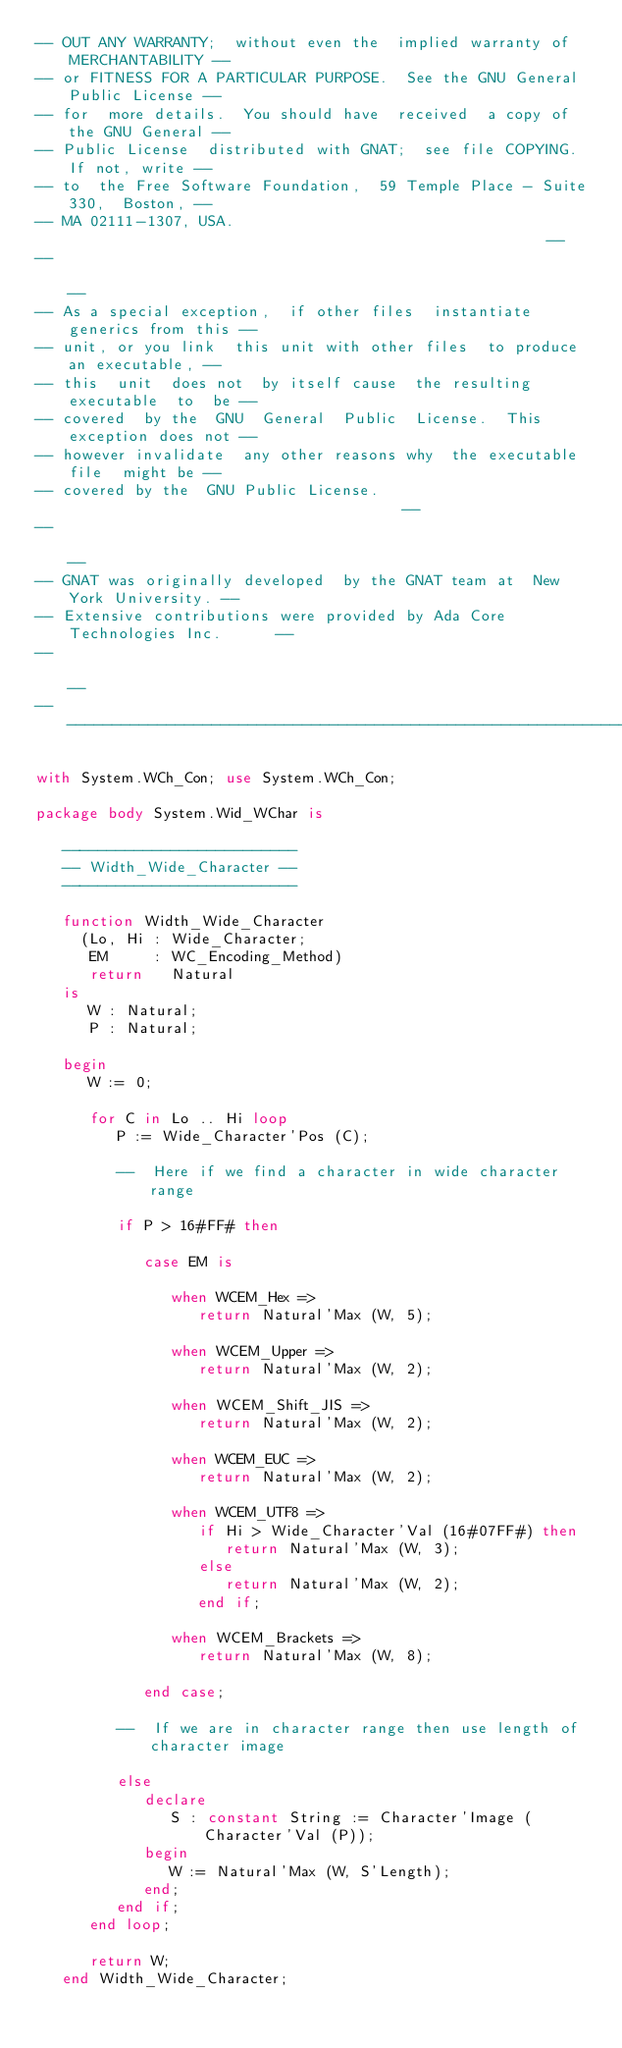<code> <loc_0><loc_0><loc_500><loc_500><_Ada_>-- OUT ANY WARRANTY;  without even the  implied warranty of MERCHANTABILITY --
-- or FITNESS FOR A PARTICULAR PURPOSE.  See the GNU General Public License --
-- for  more details.  You should have  received  a copy of the GNU General --
-- Public License  distributed with GNAT;  see file COPYING.  If not, write --
-- to  the Free Software Foundation,  59 Temple Place - Suite 330,  Boston, --
-- MA 02111-1307, USA.                                                      --
--                                                                          --
-- As a special exception,  if other files  instantiate  generics from this --
-- unit, or you link  this unit with other files  to produce an executable, --
-- this  unit  does not  by itself cause  the resulting  executable  to  be --
-- covered  by the  GNU  General  Public  License.  This exception does not --
-- however invalidate  any other reasons why  the executable file  might be --
-- covered by the  GNU Public License.                                      --
--                                                                          --
-- GNAT was originally developed  by the GNAT team at  New York University. --
-- Extensive contributions were provided by Ada Core Technologies Inc.      --
--                                                                          --
------------------------------------------------------------------------------

with System.WCh_Con; use System.WCh_Con;

package body System.Wid_WChar is

   --------------------------
   -- Width_Wide_Character --
   --------------------------

   function Width_Wide_Character
     (Lo, Hi : Wide_Character;
      EM     : WC_Encoding_Method)
      return   Natural
   is
      W : Natural;
      P : Natural;

   begin
      W := 0;

      for C in Lo .. Hi loop
         P := Wide_Character'Pos (C);

         --  Here if we find a character in wide character range

         if P > 16#FF# then

            case EM is

               when WCEM_Hex =>
                  return Natural'Max (W, 5);

               when WCEM_Upper =>
                  return Natural'Max (W, 2);

               when WCEM_Shift_JIS =>
                  return Natural'Max (W, 2);

               when WCEM_EUC =>
                  return Natural'Max (W, 2);

               when WCEM_UTF8 =>
                  if Hi > Wide_Character'Val (16#07FF#) then
                     return Natural'Max (W, 3);
                  else
                     return Natural'Max (W, 2);
                  end if;

               when WCEM_Brackets =>
                  return Natural'Max (W, 8);

            end case;

         --  If we are in character range then use length of character image

         else
            declare
               S : constant String := Character'Image (Character'Val (P));
            begin
               W := Natural'Max (W, S'Length);
            end;
         end if;
      end loop;

      return W;
   end Width_Wide_Character;
</code> 